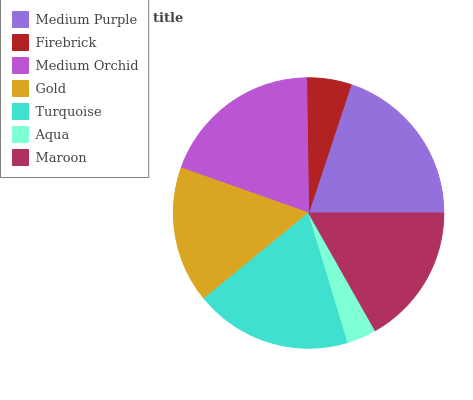Is Aqua the minimum?
Answer yes or no. Yes. Is Medium Purple the maximum?
Answer yes or no. Yes. Is Firebrick the minimum?
Answer yes or no. No. Is Firebrick the maximum?
Answer yes or no. No. Is Medium Purple greater than Firebrick?
Answer yes or no. Yes. Is Firebrick less than Medium Purple?
Answer yes or no. Yes. Is Firebrick greater than Medium Purple?
Answer yes or no. No. Is Medium Purple less than Firebrick?
Answer yes or no. No. Is Maroon the high median?
Answer yes or no. Yes. Is Maroon the low median?
Answer yes or no. Yes. Is Medium Purple the high median?
Answer yes or no. No. Is Turquoise the low median?
Answer yes or no. No. 